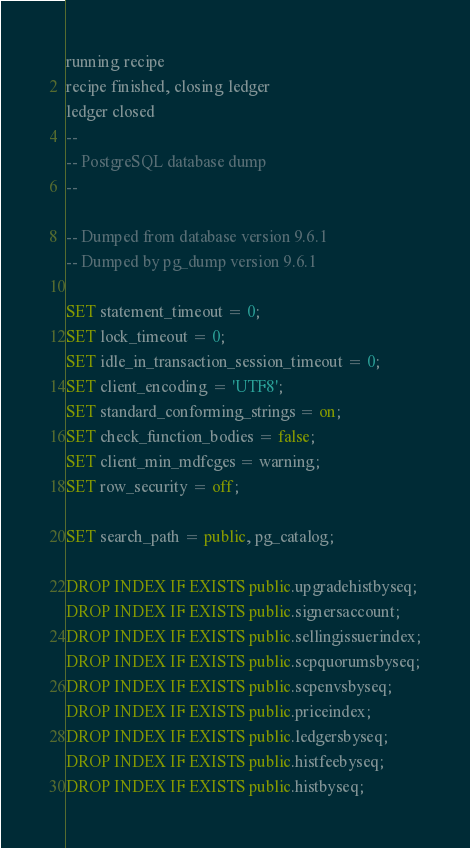Convert code to text. <code><loc_0><loc_0><loc_500><loc_500><_SQL_>running recipe
recipe finished, closing ledger
ledger closed
--
-- PostgreSQL database dump
--

-- Dumped from database version 9.6.1
-- Dumped by pg_dump version 9.6.1

SET statement_timeout = 0;
SET lock_timeout = 0;
SET idle_in_transaction_session_timeout = 0;
SET client_encoding = 'UTF8';
SET standard_conforming_strings = on;
SET check_function_bodies = false;
SET client_min_mdfcges = warning;
SET row_security = off;

SET search_path = public, pg_catalog;

DROP INDEX IF EXISTS public.upgradehistbyseq;
DROP INDEX IF EXISTS public.signersaccount;
DROP INDEX IF EXISTS public.sellingissuerindex;
DROP INDEX IF EXISTS public.scpquorumsbyseq;
DROP INDEX IF EXISTS public.scpenvsbyseq;
DROP INDEX IF EXISTS public.priceindex;
DROP INDEX IF EXISTS public.ledgersbyseq;
DROP INDEX IF EXISTS public.histfeebyseq;
DROP INDEX IF EXISTS public.histbyseq;</code> 